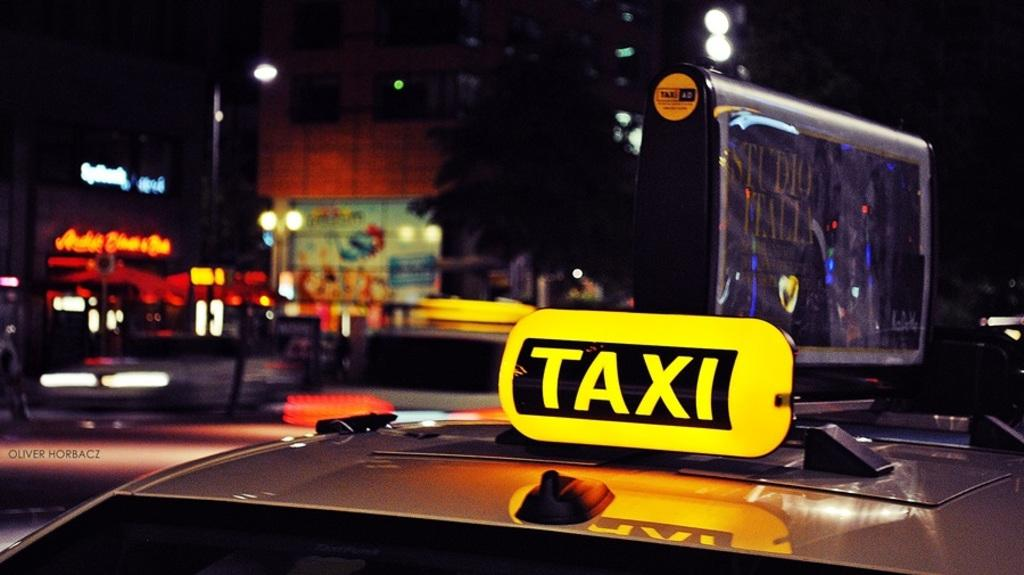<image>
Offer a succinct explanation of the picture presented. A vehicle with a TAXI sign placed on the car as it is outside in the city at night time. 